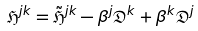Convert formula to latex. <formula><loc_0><loc_0><loc_500><loc_500>\mathfrak { H } ^ { j k } = \tilde { \mathfrak { H } } ^ { j k } - \beta ^ { j } \mathfrak { D } ^ { k } + \beta ^ { k } \mathfrak { D } ^ { j }</formula> 